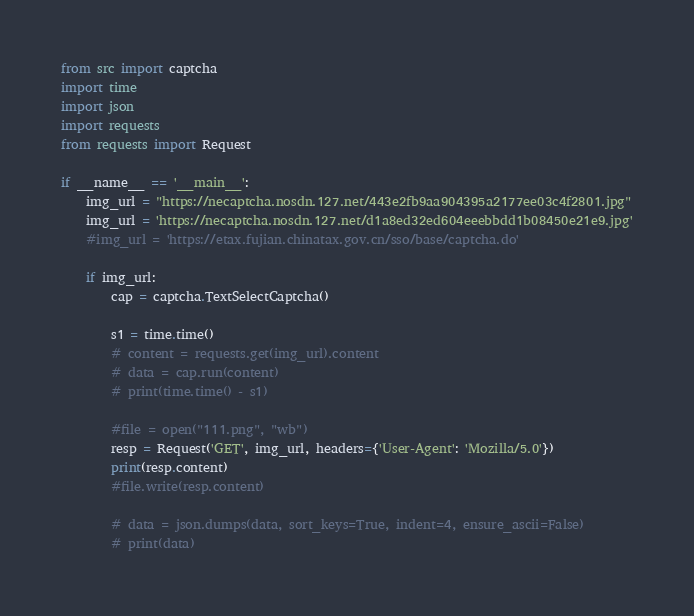Convert code to text. <code><loc_0><loc_0><loc_500><loc_500><_Python_>from src import captcha
import time
import json
import requests
from requests import Request

if __name__ == '__main__':
    img_url = "https://necaptcha.nosdn.127.net/443e2fb9aa904395a2177ee03c4f2801.jpg"
    img_url = 'https://necaptcha.nosdn.127.net/d1a8ed32ed604eeebbdd1b08450e21e9.jpg'
    #img_url = 'https://etax.fujian.chinatax.gov.cn/sso/base/captcha.do'

    if img_url:
        cap = captcha.TextSelectCaptcha()

        s1 = time.time()
        # content = requests.get(img_url).content
        # data = cap.run(content)
        # print(time.time() - s1)

        #file = open("111.png", "wb")
        resp = Request('GET', img_url, headers={'User-Agent': 'Mozilla/5.0'})
        print(resp.content)
        #file.write(resp.content)

        # data = json.dumps(data, sort_keys=True, indent=4, ensure_ascii=False)
        # print(data)
</code> 